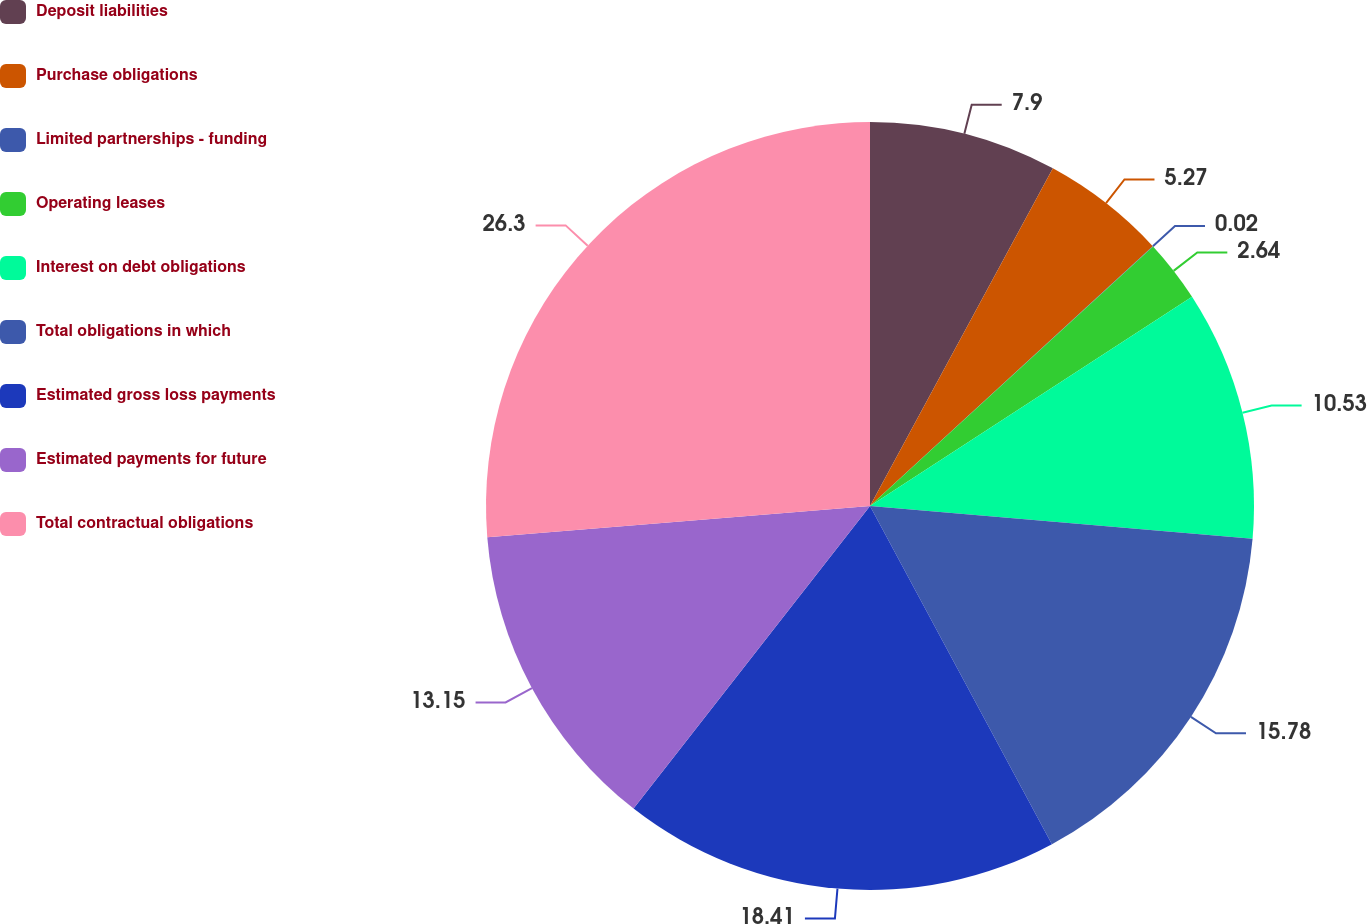Convert chart to OTSL. <chart><loc_0><loc_0><loc_500><loc_500><pie_chart><fcel>Deposit liabilities<fcel>Purchase obligations<fcel>Limited partnerships - funding<fcel>Operating leases<fcel>Interest on debt obligations<fcel>Total obligations in which<fcel>Estimated gross loss payments<fcel>Estimated payments for future<fcel>Total contractual obligations<nl><fcel>7.9%<fcel>5.27%<fcel>0.02%<fcel>2.64%<fcel>10.53%<fcel>15.78%<fcel>18.41%<fcel>13.15%<fcel>26.29%<nl></chart> 